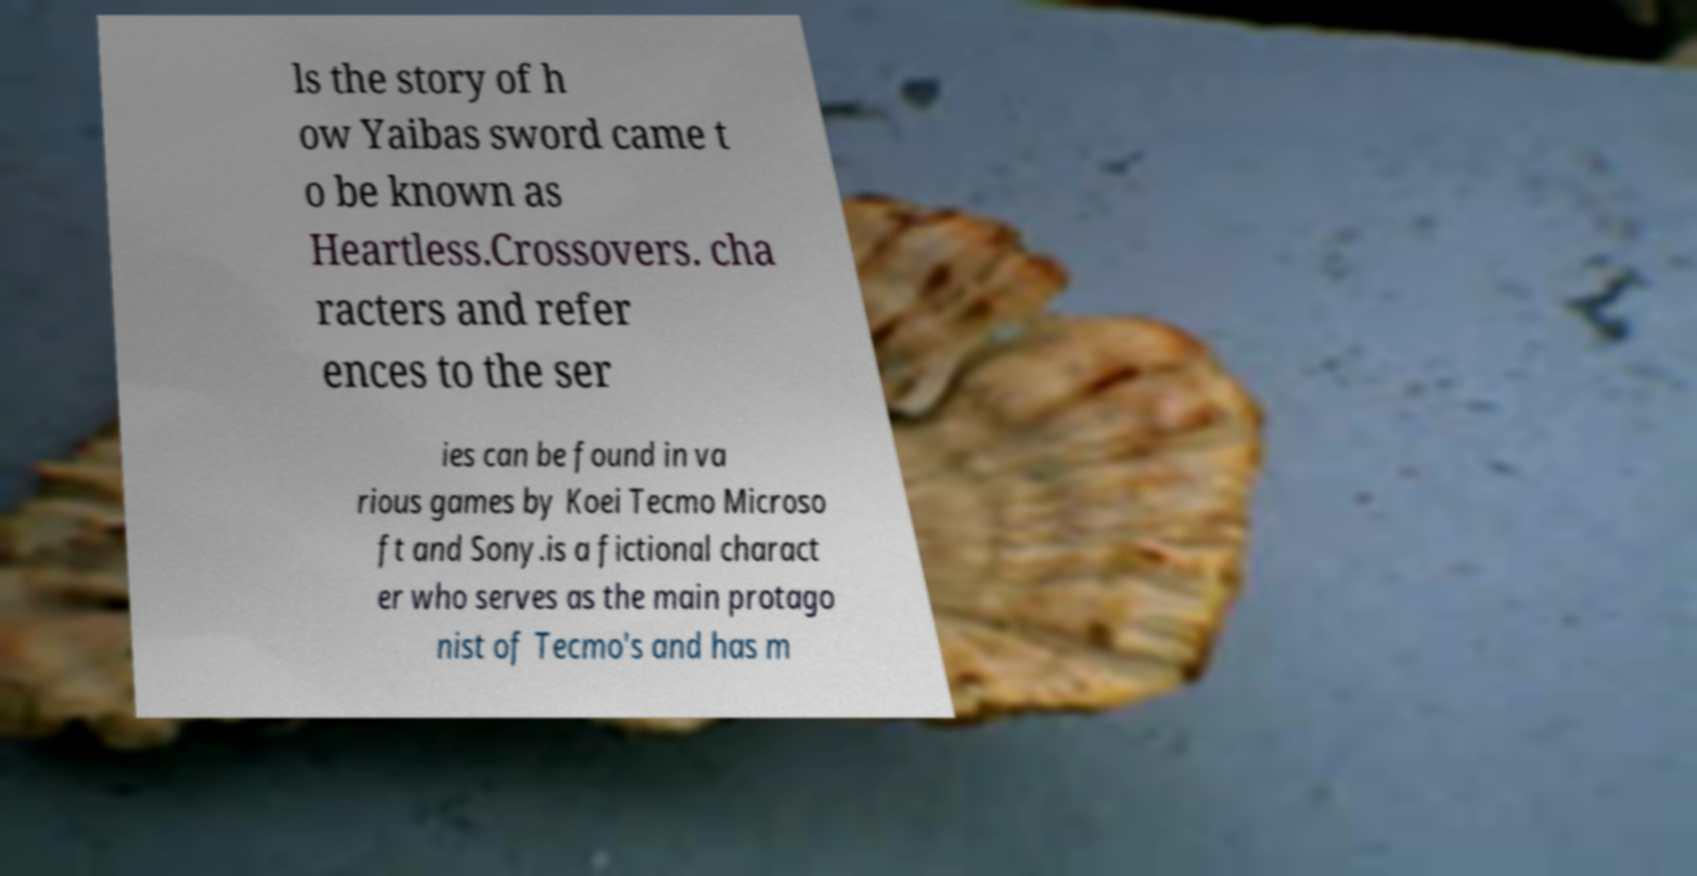Can you accurately transcribe the text from the provided image for me? ls the story of h ow Yaibas sword came t o be known as Heartless.Crossovers. cha racters and refer ences to the ser ies can be found in va rious games by Koei Tecmo Microso ft and Sony.is a fictional charact er who serves as the main protago nist of Tecmo's and has m 